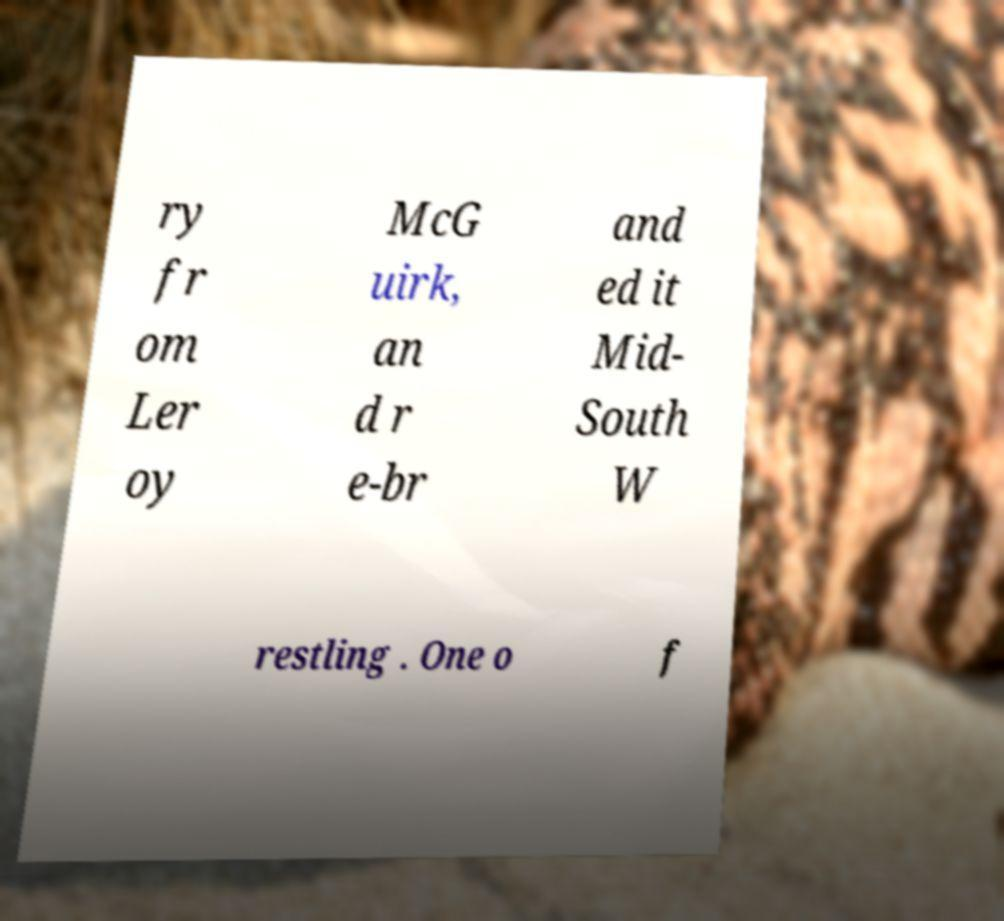What messages or text are displayed in this image? I need them in a readable, typed format. ry fr om Ler oy McG uirk, an d r e-br and ed it Mid- South W restling . One o f 